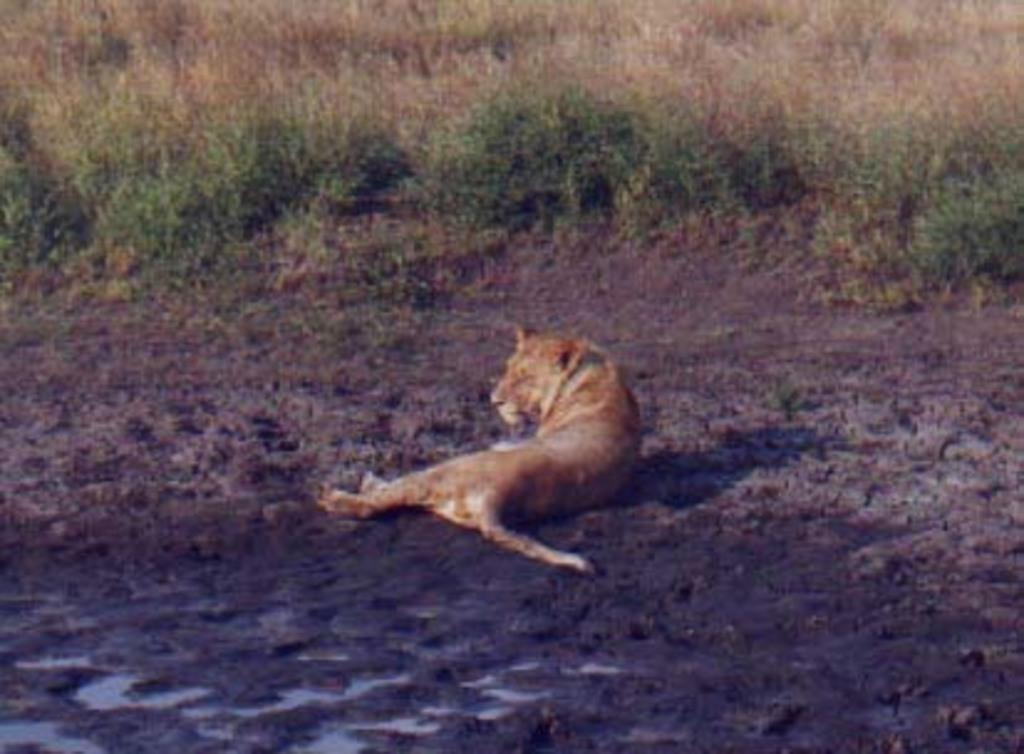What is the main subject in the middle of the image? There is a tiger in the middle of the image. What type of natural environment is visible in the background of the image? There is grass and plants in the background of the image. What type of structure can be seen in the image? There is no structure present in the image; it features a tiger in a natural environment. What type of meat is the tiger consuming in the image? There is no meat visible in the image, and tigers are not depicted as consuming any food in the image. 